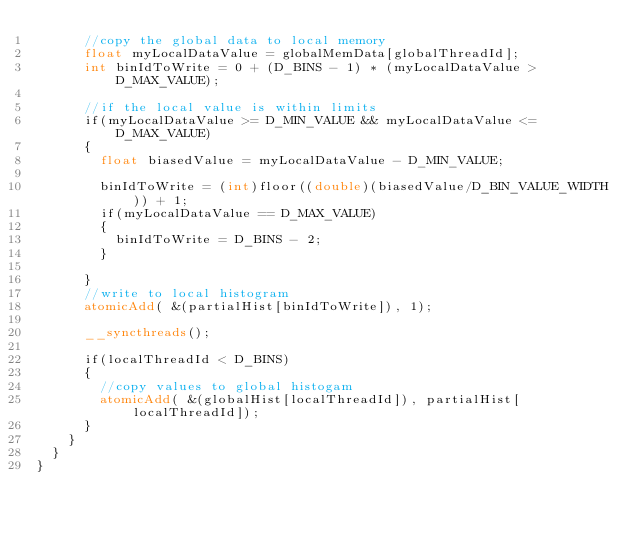Convert code to text. <code><loc_0><loc_0><loc_500><loc_500><_Cuda_>			//copy the global data to local memory
			float myLocalDataValue = globalMemData[globalThreadId];
			int binIdToWrite = 0 + (D_BINS - 1) * (myLocalDataValue > D_MAX_VALUE);

			//if the local value is within limits
			if(myLocalDataValue >= D_MIN_VALUE && myLocalDataValue <= D_MAX_VALUE)
			{
				float biasedValue = myLocalDataValue - D_MIN_VALUE;

				binIdToWrite = (int)floor((double)(biasedValue/D_BIN_VALUE_WIDTH)) + 1;
				if(myLocalDataValue == D_MAX_VALUE)
				{
					binIdToWrite = D_BINS - 2;
				}
				
			}
			//write to local histogram
			atomicAdd( &(partialHist[binIdToWrite]), 1);

			__syncthreads();

			if(localThreadId < D_BINS)
			{
				//copy values to global histogam
				atomicAdd( &(globalHist[localThreadId]), partialHist[localThreadId]);
			}
		}
	}
}</code> 